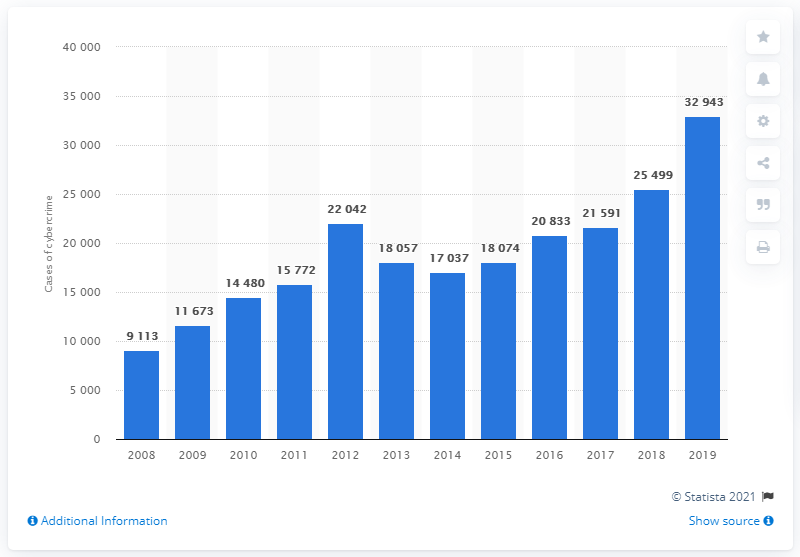Highlight a few significant elements in this photo. In 2018, the Belgian Federal Police reported the highest number of cyber-criminals. 